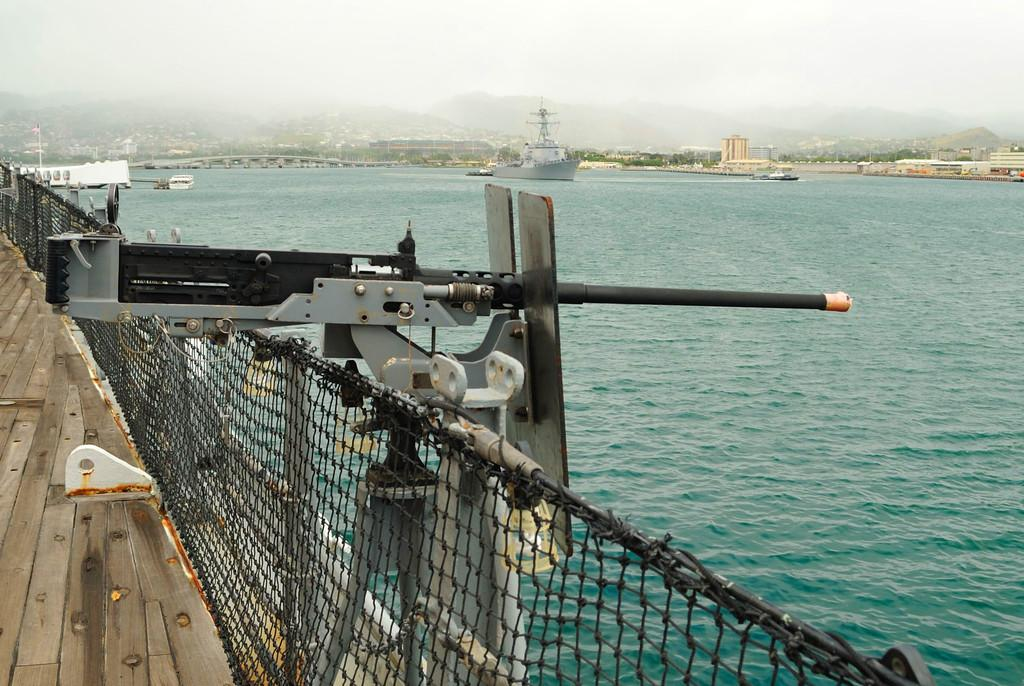What is located on the left side of the image? There is a ship on the left side of the image. Can you describe the background of the image? There are ships visible in the background of the image, and there are mountains in the background as well. Where are the ships situated in the image? The ships are on the sea. What degree of difficulty is the meal being prepared on the ship in the image? There is no meal being prepared in the image, so it's not possible to determine the degree of difficulty. 